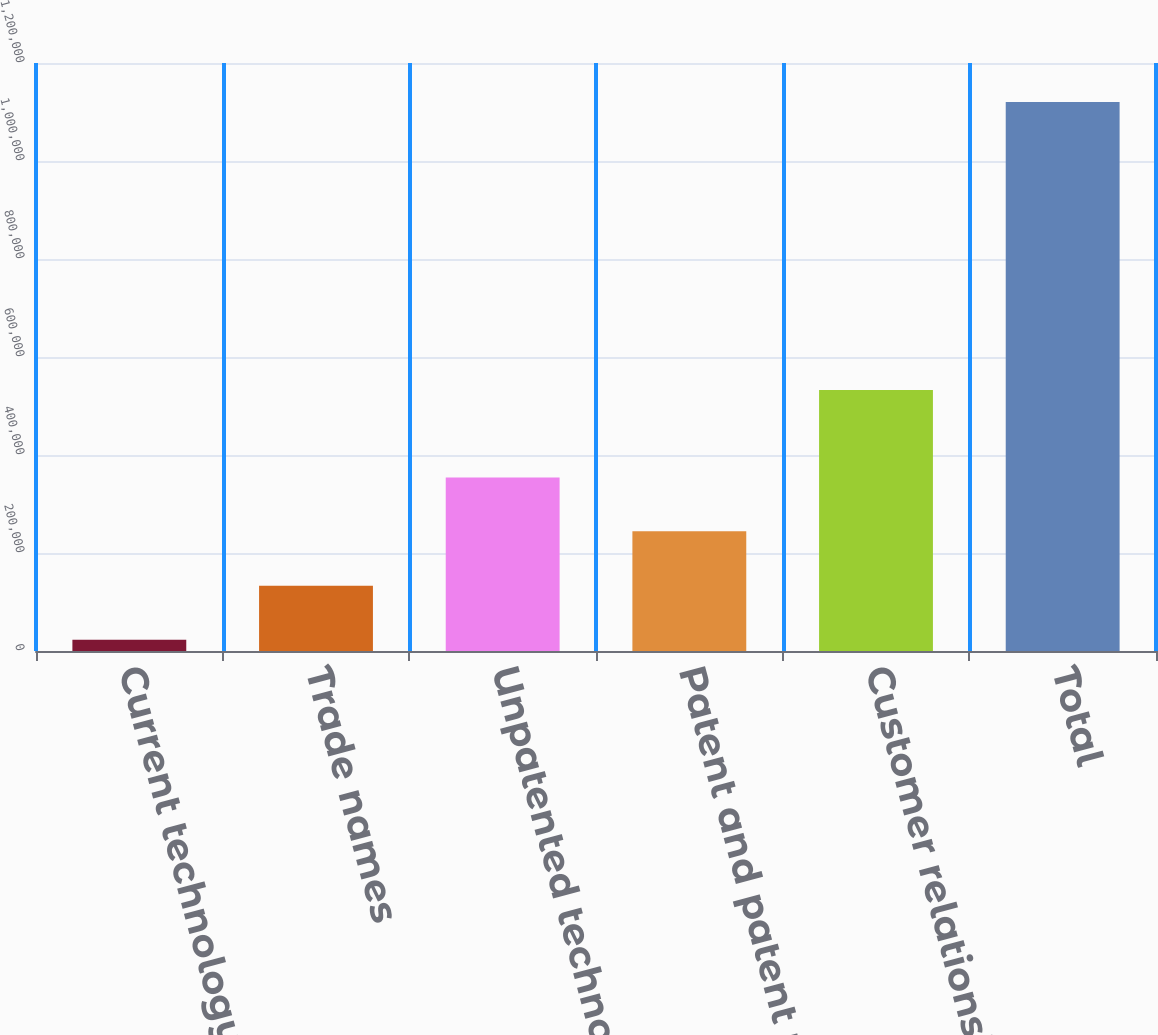<chart> <loc_0><loc_0><loc_500><loc_500><bar_chart><fcel>Current technology<fcel>Trade names<fcel>Unpatented technology<fcel>Patent and patent rights<fcel>Customer relationships<fcel>Total<nl><fcel>23201<fcel>132947<fcel>354315<fcel>244569<fcel>532591<fcel>1.12066e+06<nl></chart> 